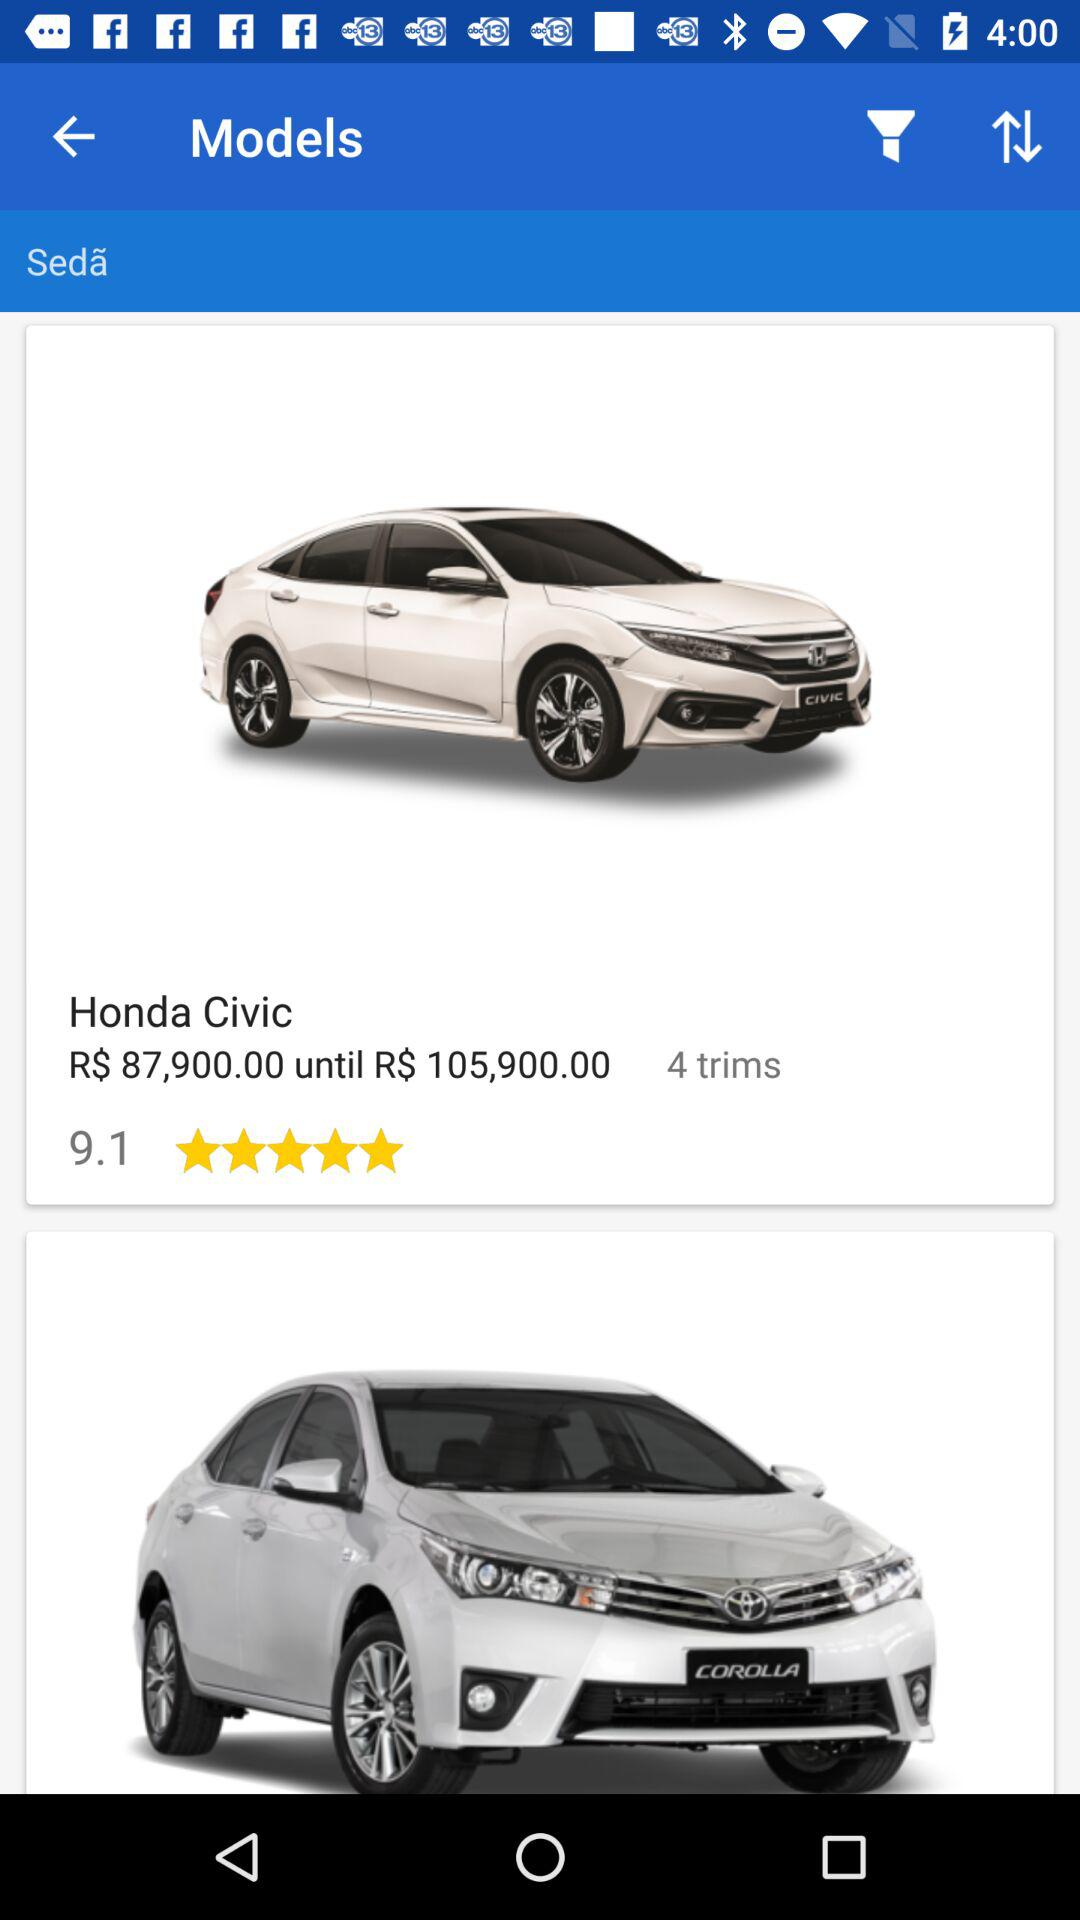What is the star rating of the car? The rating is 5 stars. 